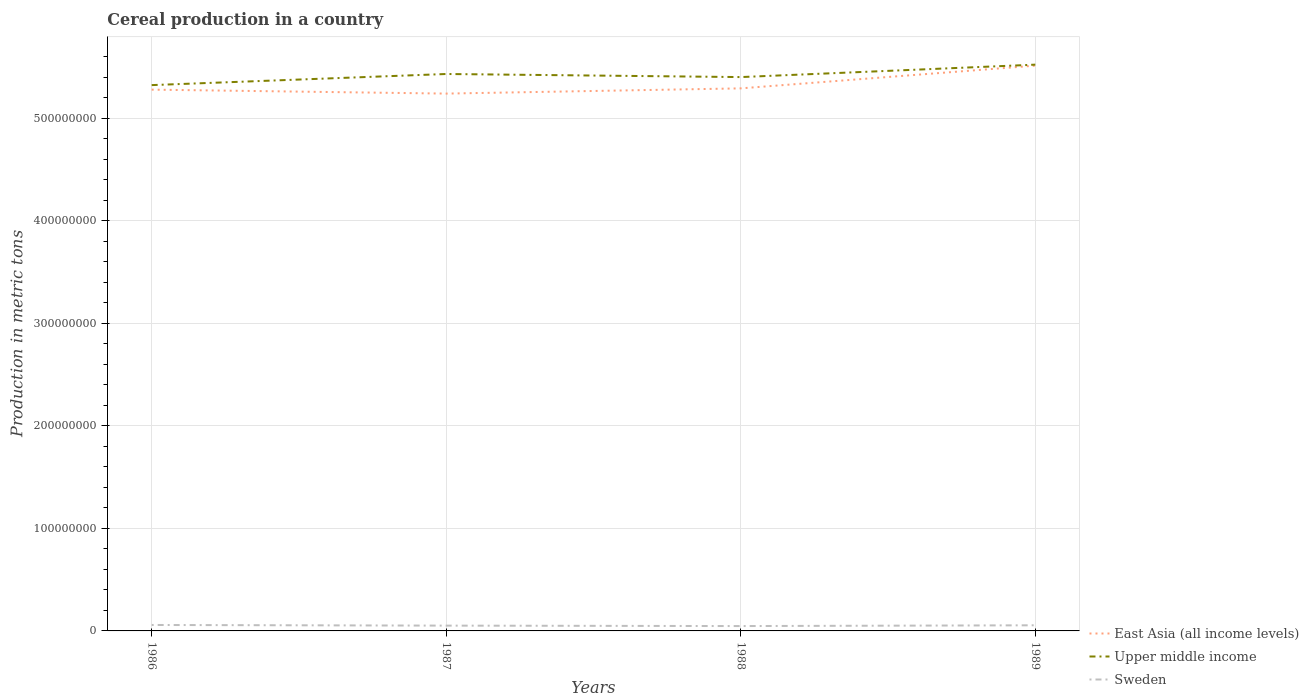Across all years, what is the maximum total cereal production in Upper middle income?
Make the answer very short. 5.33e+08. What is the total total cereal production in Upper middle income in the graph?
Your answer should be compact. -2.00e+07. What is the difference between the highest and the second highest total cereal production in East Asia (all income levels)?
Ensure brevity in your answer.  2.73e+07. Is the total cereal production in Upper middle income strictly greater than the total cereal production in East Asia (all income levels) over the years?
Give a very brief answer. No. How many lines are there?
Your answer should be very brief. 3. How many years are there in the graph?
Your answer should be very brief. 4. What is the difference between two consecutive major ticks on the Y-axis?
Give a very brief answer. 1.00e+08. Are the values on the major ticks of Y-axis written in scientific E-notation?
Provide a succinct answer. No. Does the graph contain any zero values?
Your answer should be very brief. No. Does the graph contain grids?
Your answer should be very brief. Yes. Where does the legend appear in the graph?
Offer a very short reply. Bottom right. How are the legend labels stacked?
Keep it short and to the point. Vertical. What is the title of the graph?
Your answer should be compact. Cereal production in a country. Does "Argentina" appear as one of the legend labels in the graph?
Your answer should be compact. No. What is the label or title of the X-axis?
Your answer should be very brief. Years. What is the label or title of the Y-axis?
Your answer should be compact. Production in metric tons. What is the Production in metric tons in East Asia (all income levels) in 1986?
Your response must be concise. 5.28e+08. What is the Production in metric tons of Upper middle income in 1986?
Offer a terse response. 5.33e+08. What is the Production in metric tons in Sweden in 1986?
Your response must be concise. 5.81e+06. What is the Production in metric tons of East Asia (all income levels) in 1987?
Offer a very short reply. 5.24e+08. What is the Production in metric tons in Upper middle income in 1987?
Keep it short and to the point. 5.43e+08. What is the Production in metric tons of Sweden in 1987?
Keep it short and to the point. 5.17e+06. What is the Production in metric tons of East Asia (all income levels) in 1988?
Provide a short and direct response. 5.29e+08. What is the Production in metric tons in Upper middle income in 1988?
Provide a short and direct response. 5.40e+08. What is the Production in metric tons of Sweden in 1988?
Offer a terse response. 4.74e+06. What is the Production in metric tons in East Asia (all income levels) in 1989?
Give a very brief answer. 5.52e+08. What is the Production in metric tons in Upper middle income in 1989?
Offer a very short reply. 5.53e+08. What is the Production in metric tons of Sweden in 1989?
Your answer should be very brief. 5.49e+06. Across all years, what is the maximum Production in metric tons of East Asia (all income levels)?
Provide a short and direct response. 5.52e+08. Across all years, what is the maximum Production in metric tons of Upper middle income?
Offer a terse response. 5.53e+08. Across all years, what is the maximum Production in metric tons of Sweden?
Give a very brief answer. 5.81e+06. Across all years, what is the minimum Production in metric tons in East Asia (all income levels)?
Give a very brief answer. 5.24e+08. Across all years, what is the minimum Production in metric tons in Upper middle income?
Provide a short and direct response. 5.33e+08. Across all years, what is the minimum Production in metric tons of Sweden?
Provide a succinct answer. 4.74e+06. What is the total Production in metric tons in East Asia (all income levels) in the graph?
Make the answer very short. 2.13e+09. What is the total Production in metric tons of Upper middle income in the graph?
Make the answer very short. 2.17e+09. What is the total Production in metric tons of Sweden in the graph?
Provide a succinct answer. 2.12e+07. What is the difference between the Production in metric tons in East Asia (all income levels) in 1986 and that in 1987?
Offer a terse response. 3.86e+06. What is the difference between the Production in metric tons in Upper middle income in 1986 and that in 1987?
Your answer should be compact. -1.08e+07. What is the difference between the Production in metric tons in Sweden in 1986 and that in 1987?
Offer a very short reply. 6.40e+05. What is the difference between the Production in metric tons of East Asia (all income levels) in 1986 and that in 1988?
Your answer should be very brief. -1.25e+06. What is the difference between the Production in metric tons of Upper middle income in 1986 and that in 1988?
Provide a succinct answer. -7.83e+06. What is the difference between the Production in metric tons in Sweden in 1986 and that in 1988?
Make the answer very short. 1.07e+06. What is the difference between the Production in metric tons of East Asia (all income levels) in 1986 and that in 1989?
Give a very brief answer. -2.34e+07. What is the difference between the Production in metric tons of Upper middle income in 1986 and that in 1989?
Your answer should be very brief. -2.00e+07. What is the difference between the Production in metric tons in Sweden in 1986 and that in 1989?
Provide a short and direct response. 3.18e+05. What is the difference between the Production in metric tons of East Asia (all income levels) in 1987 and that in 1988?
Offer a very short reply. -5.11e+06. What is the difference between the Production in metric tons of Upper middle income in 1987 and that in 1988?
Your answer should be very brief. 3.01e+06. What is the difference between the Production in metric tons of Sweden in 1987 and that in 1988?
Your answer should be very brief. 4.27e+05. What is the difference between the Production in metric tons in East Asia (all income levels) in 1987 and that in 1989?
Provide a short and direct response. -2.73e+07. What is the difference between the Production in metric tons of Upper middle income in 1987 and that in 1989?
Keep it short and to the point. -9.12e+06. What is the difference between the Production in metric tons in Sweden in 1987 and that in 1989?
Provide a short and direct response. -3.22e+05. What is the difference between the Production in metric tons in East Asia (all income levels) in 1988 and that in 1989?
Provide a short and direct response. -2.22e+07. What is the difference between the Production in metric tons of Upper middle income in 1988 and that in 1989?
Ensure brevity in your answer.  -1.21e+07. What is the difference between the Production in metric tons of Sweden in 1988 and that in 1989?
Your answer should be compact. -7.49e+05. What is the difference between the Production in metric tons of East Asia (all income levels) in 1986 and the Production in metric tons of Upper middle income in 1987?
Give a very brief answer. -1.53e+07. What is the difference between the Production in metric tons of East Asia (all income levels) in 1986 and the Production in metric tons of Sweden in 1987?
Offer a very short reply. 5.23e+08. What is the difference between the Production in metric tons of Upper middle income in 1986 and the Production in metric tons of Sweden in 1987?
Provide a succinct answer. 5.27e+08. What is the difference between the Production in metric tons of East Asia (all income levels) in 1986 and the Production in metric tons of Upper middle income in 1988?
Offer a very short reply. -1.23e+07. What is the difference between the Production in metric tons in East Asia (all income levels) in 1986 and the Production in metric tons in Sweden in 1988?
Your response must be concise. 5.23e+08. What is the difference between the Production in metric tons in Upper middle income in 1986 and the Production in metric tons in Sweden in 1988?
Make the answer very short. 5.28e+08. What is the difference between the Production in metric tons in East Asia (all income levels) in 1986 and the Production in metric tons in Upper middle income in 1989?
Offer a very short reply. -2.44e+07. What is the difference between the Production in metric tons of East Asia (all income levels) in 1986 and the Production in metric tons of Sweden in 1989?
Your answer should be compact. 5.23e+08. What is the difference between the Production in metric tons of Upper middle income in 1986 and the Production in metric tons of Sweden in 1989?
Your answer should be compact. 5.27e+08. What is the difference between the Production in metric tons in East Asia (all income levels) in 1987 and the Production in metric tons in Upper middle income in 1988?
Provide a short and direct response. -1.61e+07. What is the difference between the Production in metric tons in East Asia (all income levels) in 1987 and the Production in metric tons in Sweden in 1988?
Make the answer very short. 5.20e+08. What is the difference between the Production in metric tons of Upper middle income in 1987 and the Production in metric tons of Sweden in 1988?
Your answer should be compact. 5.39e+08. What is the difference between the Production in metric tons of East Asia (all income levels) in 1987 and the Production in metric tons of Upper middle income in 1989?
Provide a succinct answer. -2.82e+07. What is the difference between the Production in metric tons in East Asia (all income levels) in 1987 and the Production in metric tons in Sweden in 1989?
Your answer should be compact. 5.19e+08. What is the difference between the Production in metric tons of Upper middle income in 1987 and the Production in metric tons of Sweden in 1989?
Provide a short and direct response. 5.38e+08. What is the difference between the Production in metric tons of East Asia (all income levels) in 1988 and the Production in metric tons of Upper middle income in 1989?
Give a very brief answer. -2.31e+07. What is the difference between the Production in metric tons in East Asia (all income levels) in 1988 and the Production in metric tons in Sweden in 1989?
Offer a terse response. 5.24e+08. What is the difference between the Production in metric tons of Upper middle income in 1988 and the Production in metric tons of Sweden in 1989?
Offer a very short reply. 5.35e+08. What is the average Production in metric tons of East Asia (all income levels) per year?
Ensure brevity in your answer.  5.33e+08. What is the average Production in metric tons in Upper middle income per year?
Offer a very short reply. 5.42e+08. What is the average Production in metric tons in Sweden per year?
Your answer should be very brief. 5.30e+06. In the year 1986, what is the difference between the Production in metric tons of East Asia (all income levels) and Production in metric tons of Upper middle income?
Make the answer very short. -4.42e+06. In the year 1986, what is the difference between the Production in metric tons in East Asia (all income levels) and Production in metric tons in Sweden?
Ensure brevity in your answer.  5.22e+08. In the year 1986, what is the difference between the Production in metric tons in Upper middle income and Production in metric tons in Sweden?
Offer a very short reply. 5.27e+08. In the year 1987, what is the difference between the Production in metric tons in East Asia (all income levels) and Production in metric tons in Upper middle income?
Keep it short and to the point. -1.91e+07. In the year 1987, what is the difference between the Production in metric tons of East Asia (all income levels) and Production in metric tons of Sweden?
Your answer should be very brief. 5.19e+08. In the year 1987, what is the difference between the Production in metric tons of Upper middle income and Production in metric tons of Sweden?
Provide a succinct answer. 5.38e+08. In the year 1988, what is the difference between the Production in metric tons in East Asia (all income levels) and Production in metric tons in Upper middle income?
Provide a succinct answer. -1.10e+07. In the year 1988, what is the difference between the Production in metric tons of East Asia (all income levels) and Production in metric tons of Sweden?
Offer a very short reply. 5.25e+08. In the year 1988, what is the difference between the Production in metric tons of Upper middle income and Production in metric tons of Sweden?
Your response must be concise. 5.36e+08. In the year 1989, what is the difference between the Production in metric tons in East Asia (all income levels) and Production in metric tons in Upper middle income?
Provide a succinct answer. -9.60e+05. In the year 1989, what is the difference between the Production in metric tons in East Asia (all income levels) and Production in metric tons in Sweden?
Your response must be concise. 5.46e+08. In the year 1989, what is the difference between the Production in metric tons in Upper middle income and Production in metric tons in Sweden?
Your answer should be compact. 5.47e+08. What is the ratio of the Production in metric tons in East Asia (all income levels) in 1986 to that in 1987?
Offer a terse response. 1.01. What is the ratio of the Production in metric tons of Sweden in 1986 to that in 1987?
Provide a short and direct response. 1.12. What is the ratio of the Production in metric tons in East Asia (all income levels) in 1986 to that in 1988?
Offer a very short reply. 1. What is the ratio of the Production in metric tons in Upper middle income in 1986 to that in 1988?
Ensure brevity in your answer.  0.99. What is the ratio of the Production in metric tons of Sweden in 1986 to that in 1988?
Keep it short and to the point. 1.23. What is the ratio of the Production in metric tons of East Asia (all income levels) in 1986 to that in 1989?
Ensure brevity in your answer.  0.96. What is the ratio of the Production in metric tons of Upper middle income in 1986 to that in 1989?
Offer a very short reply. 0.96. What is the ratio of the Production in metric tons of Sweden in 1986 to that in 1989?
Your response must be concise. 1.06. What is the ratio of the Production in metric tons in Upper middle income in 1987 to that in 1988?
Keep it short and to the point. 1.01. What is the ratio of the Production in metric tons in Sweden in 1987 to that in 1988?
Keep it short and to the point. 1.09. What is the ratio of the Production in metric tons in East Asia (all income levels) in 1987 to that in 1989?
Your answer should be compact. 0.95. What is the ratio of the Production in metric tons of Upper middle income in 1987 to that in 1989?
Give a very brief answer. 0.98. What is the ratio of the Production in metric tons of Sweden in 1987 to that in 1989?
Keep it short and to the point. 0.94. What is the ratio of the Production in metric tons of East Asia (all income levels) in 1988 to that in 1989?
Your answer should be very brief. 0.96. What is the ratio of the Production in metric tons of Upper middle income in 1988 to that in 1989?
Your answer should be very brief. 0.98. What is the ratio of the Production in metric tons in Sweden in 1988 to that in 1989?
Ensure brevity in your answer.  0.86. What is the difference between the highest and the second highest Production in metric tons of East Asia (all income levels)?
Your response must be concise. 2.22e+07. What is the difference between the highest and the second highest Production in metric tons in Upper middle income?
Make the answer very short. 9.12e+06. What is the difference between the highest and the second highest Production in metric tons of Sweden?
Ensure brevity in your answer.  3.18e+05. What is the difference between the highest and the lowest Production in metric tons in East Asia (all income levels)?
Keep it short and to the point. 2.73e+07. What is the difference between the highest and the lowest Production in metric tons of Upper middle income?
Ensure brevity in your answer.  2.00e+07. What is the difference between the highest and the lowest Production in metric tons of Sweden?
Provide a succinct answer. 1.07e+06. 